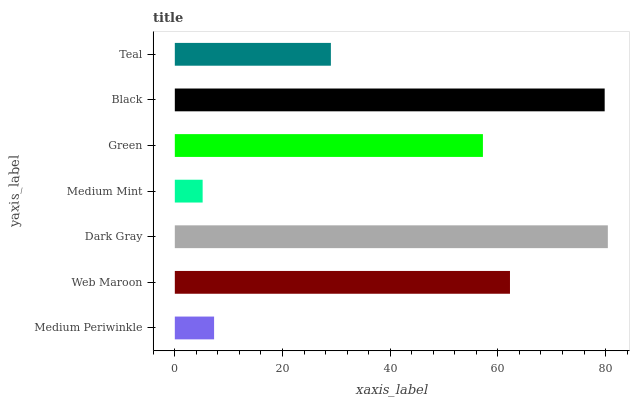Is Medium Mint the minimum?
Answer yes or no. Yes. Is Dark Gray the maximum?
Answer yes or no. Yes. Is Web Maroon the minimum?
Answer yes or no. No. Is Web Maroon the maximum?
Answer yes or no. No. Is Web Maroon greater than Medium Periwinkle?
Answer yes or no. Yes. Is Medium Periwinkle less than Web Maroon?
Answer yes or no. Yes. Is Medium Periwinkle greater than Web Maroon?
Answer yes or no. No. Is Web Maroon less than Medium Periwinkle?
Answer yes or no. No. Is Green the high median?
Answer yes or no. Yes. Is Green the low median?
Answer yes or no. Yes. Is Medium Mint the high median?
Answer yes or no. No. Is Black the low median?
Answer yes or no. No. 